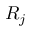Convert formula to latex. <formula><loc_0><loc_0><loc_500><loc_500>R _ { j }</formula> 